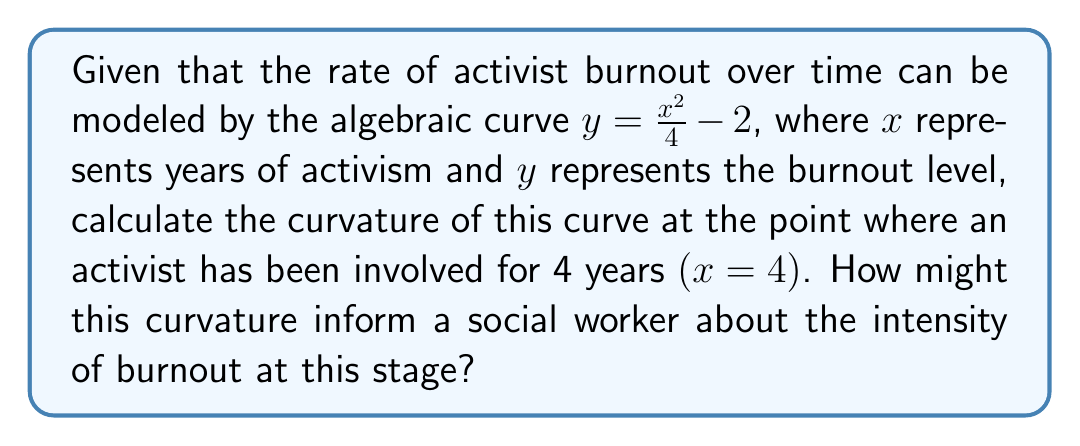Can you solve this math problem? To calculate the curvature of the given algebraic curve, we'll follow these steps:

1) The curvature formula for a function $y=f(x)$ is:

   $$\kappa = \frac{|f''(x)|}{(1 + [f'(x)]^2)^{3/2}}$$

2) First, let's find $f'(x)$ and $f''(x)$:
   
   $f(x) = \frac{x^2}{4} - 2$
   
   $f'(x) = \frac{2x}{4} = \frac{x}{2}$
   
   $f''(x) = \frac{1}{2}$

3) Now, let's evaluate $f'(x)$ at $x=4$:
   
   $f'(4) = \frac{4}{2} = 2$

4) Substitute these values into the curvature formula:

   $$\kappa = \frac{|\frac{1}{2}|}{(1 + [2]^2)^{3/2}}$$

5) Simplify:
   
   $$\kappa = \frac{0.5}{(1 + 4)^{3/2}} = \frac{0.5}{5^{3/2}} = \frac{0.5}{5\sqrt{5}} = \frac{1}{10\sqrt{5}}$$

6) Therefore, the curvature at $x=4$ is $\frac{1}{10\sqrt{5}}$.

For a social worker, this curvature value indicates the rate of change in the burnout acceleration at the 4-year mark. A positive curvature suggests that the burnout rate is increasing more rapidly at this point, which could inform interventions and support strategies for activists reaching this critical stage in their involvement.
Answer: $\frac{1}{10\sqrt{5}}$ 